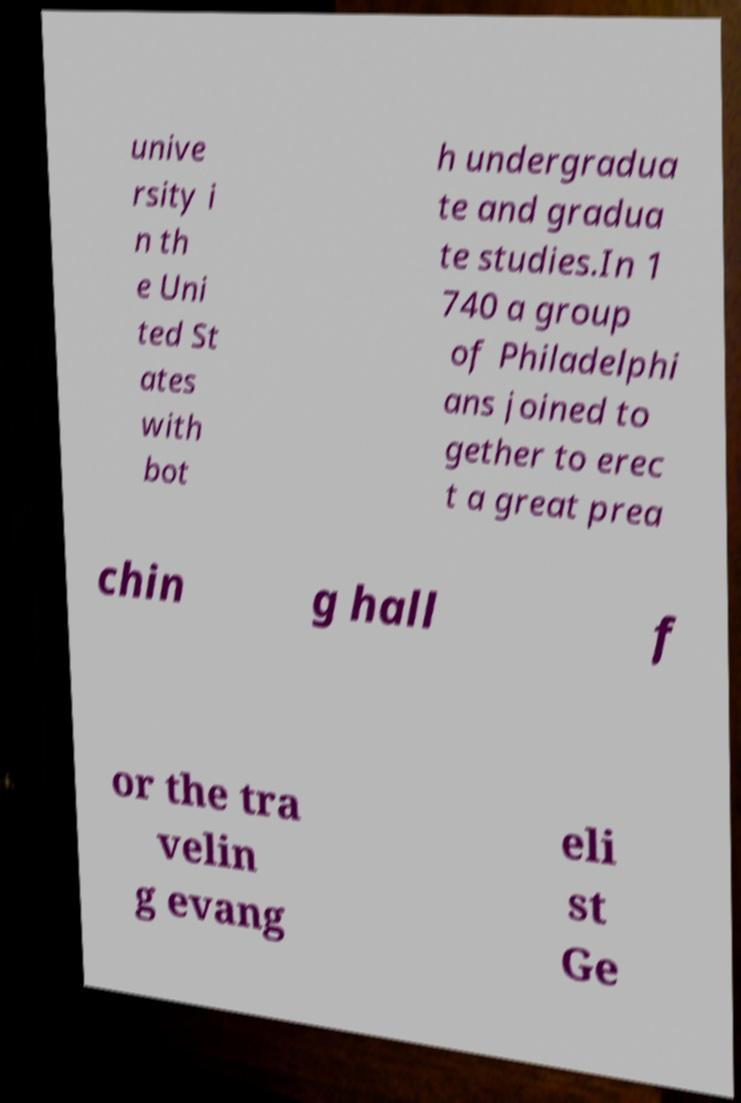I need the written content from this picture converted into text. Can you do that? unive rsity i n th e Uni ted St ates with bot h undergradua te and gradua te studies.In 1 740 a group of Philadelphi ans joined to gether to erec t a great prea chin g hall f or the tra velin g evang eli st Ge 